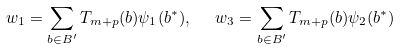Convert formula to latex. <formula><loc_0><loc_0><loc_500><loc_500>w _ { 1 } = \sum _ { b \in B ^ { \prime } } T _ { m + p } ( b ) \psi _ { 1 } ( b ^ { * } ) , \ \ w _ { 3 } = \sum _ { b \in B ^ { \prime } } T _ { m + p } ( b ) \psi _ { 2 } ( b ^ { * } )</formula> 